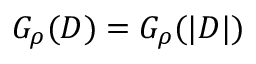Convert formula to latex. <formula><loc_0><loc_0><loc_500><loc_500>G _ { \rho } ( D ) = G _ { \rho } ( | D | )</formula> 